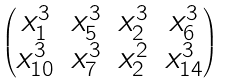<formula> <loc_0><loc_0><loc_500><loc_500>\begin{pmatrix} x _ { 1 } ^ { 3 } & x _ { 5 } ^ { 3 } & x _ { 2 } ^ { 3 } & x _ { 6 } ^ { 3 } \\ x _ { 1 0 } ^ { 3 } & x _ { 7 } ^ { 3 } & x _ { 2 } ^ { 2 } & x _ { 1 4 } ^ { 3 } \end{pmatrix}</formula> 